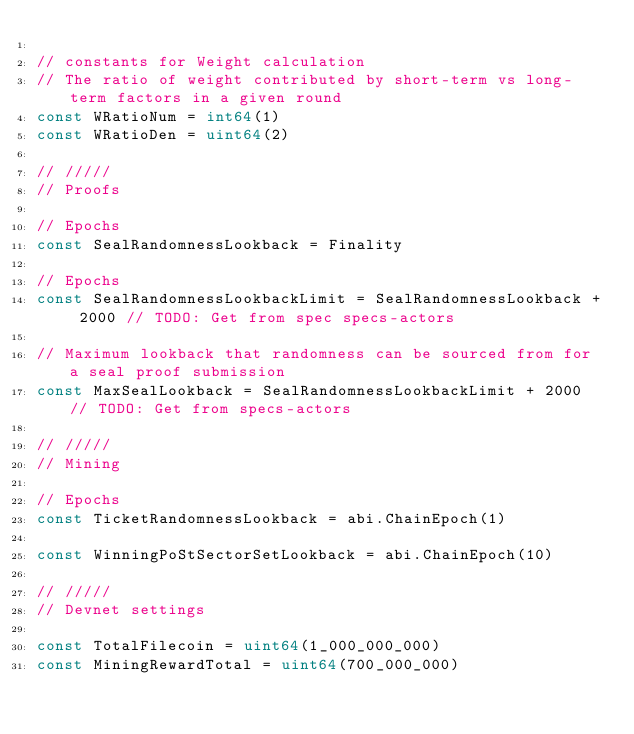<code> <loc_0><loc_0><loc_500><loc_500><_Go_>
// constants for Weight calculation
// The ratio of weight contributed by short-term vs long-term factors in a given round
const WRatioNum = int64(1)
const WRatioDen = uint64(2)

// /////
// Proofs

// Epochs
const SealRandomnessLookback = Finality

// Epochs
const SealRandomnessLookbackLimit = SealRandomnessLookback + 2000 // TODO: Get from spec specs-actors

// Maximum lookback that randomness can be sourced from for a seal proof submission
const MaxSealLookback = SealRandomnessLookbackLimit + 2000 // TODO: Get from specs-actors

// /////
// Mining

// Epochs
const TicketRandomnessLookback = abi.ChainEpoch(1)

const WinningPoStSectorSetLookback = abi.ChainEpoch(10)

// /////
// Devnet settings

const TotalFilecoin = uint64(1_000_000_000)
const MiningRewardTotal = uint64(700_000_000)
</code> 